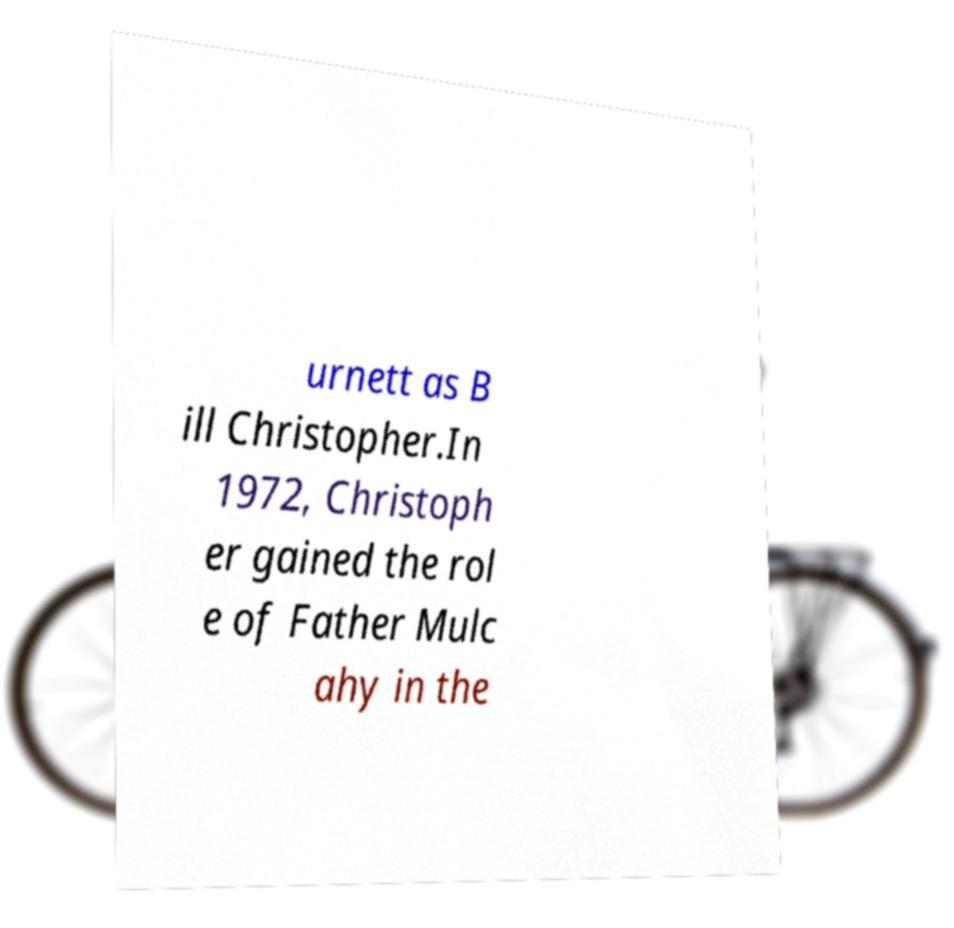Please read and relay the text visible in this image. What does it say? urnett as B ill Christopher.In 1972, Christoph er gained the rol e of Father Mulc ahy in the 